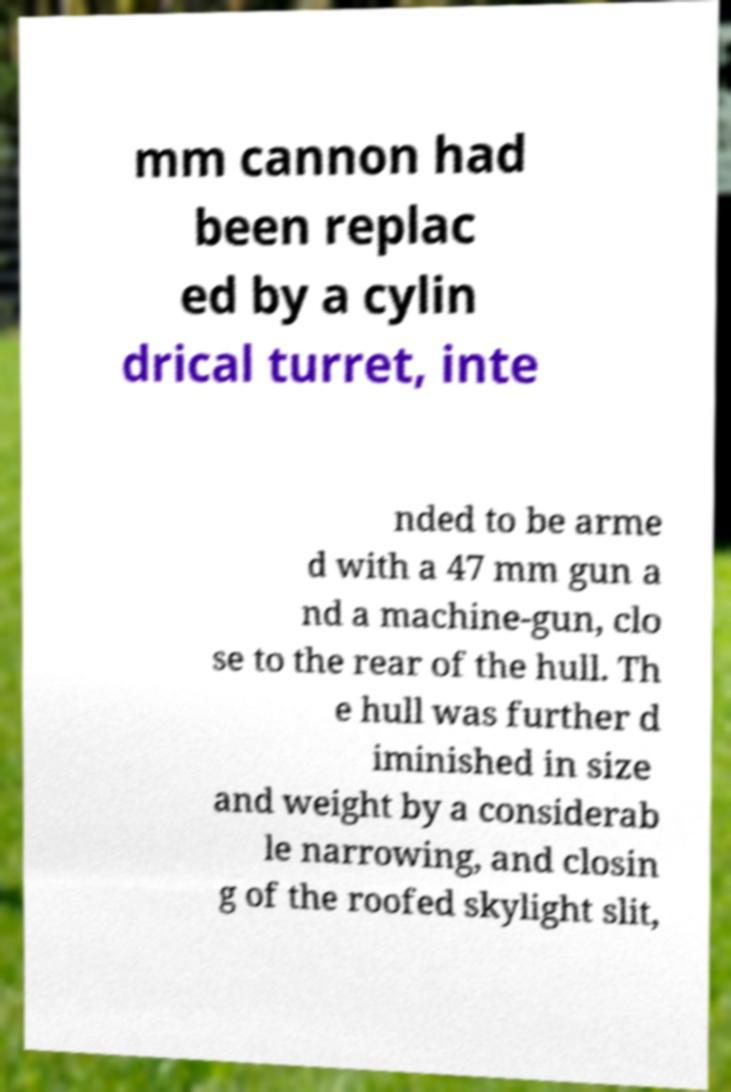Please read and relay the text visible in this image. What does it say? mm cannon had been replac ed by a cylin drical turret, inte nded to be arme d with a 47 mm gun a nd a machine-gun, clo se to the rear of the hull. Th e hull was further d iminished in size and weight by a considerab le narrowing, and closin g of the roofed skylight slit, 